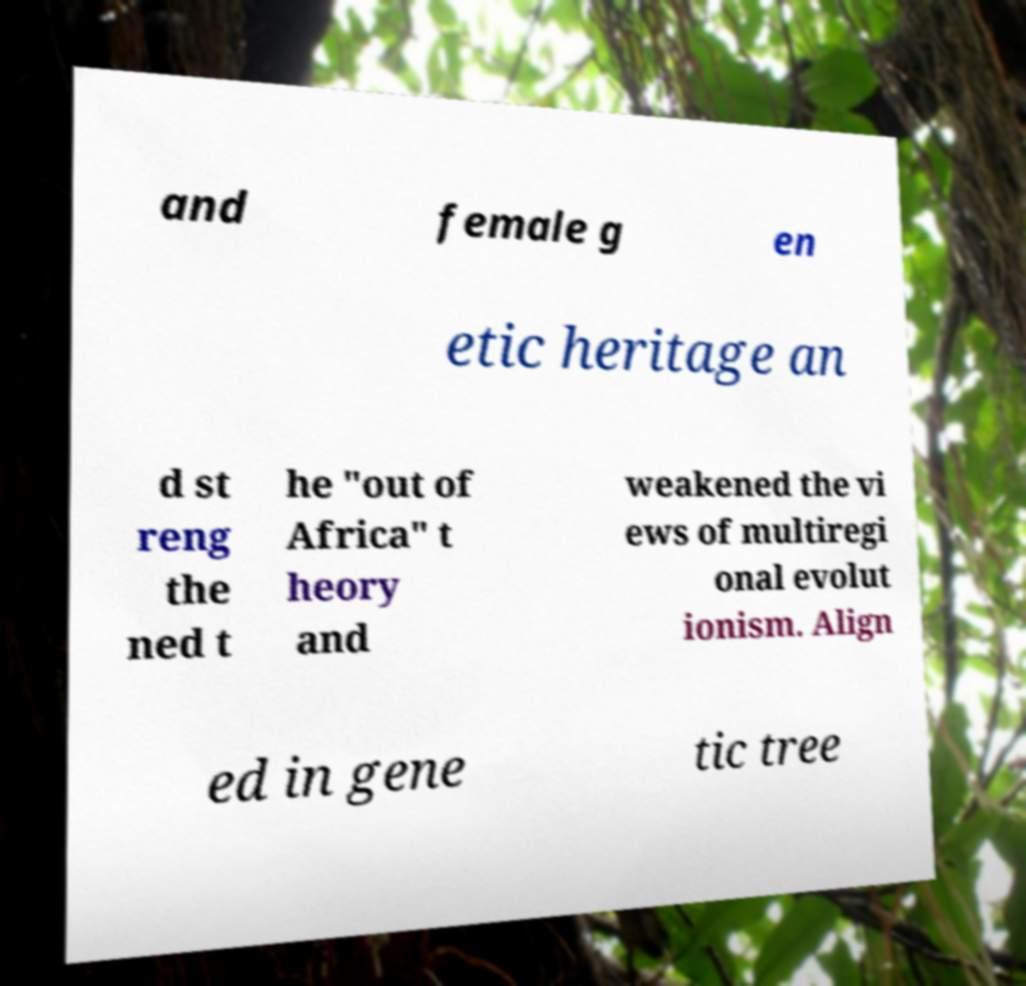Can you read and provide the text displayed in the image?This photo seems to have some interesting text. Can you extract and type it out for me? and female g en etic heritage an d st reng the ned t he "out of Africa" t heory and weakened the vi ews of multiregi onal evolut ionism. Align ed in gene tic tree 